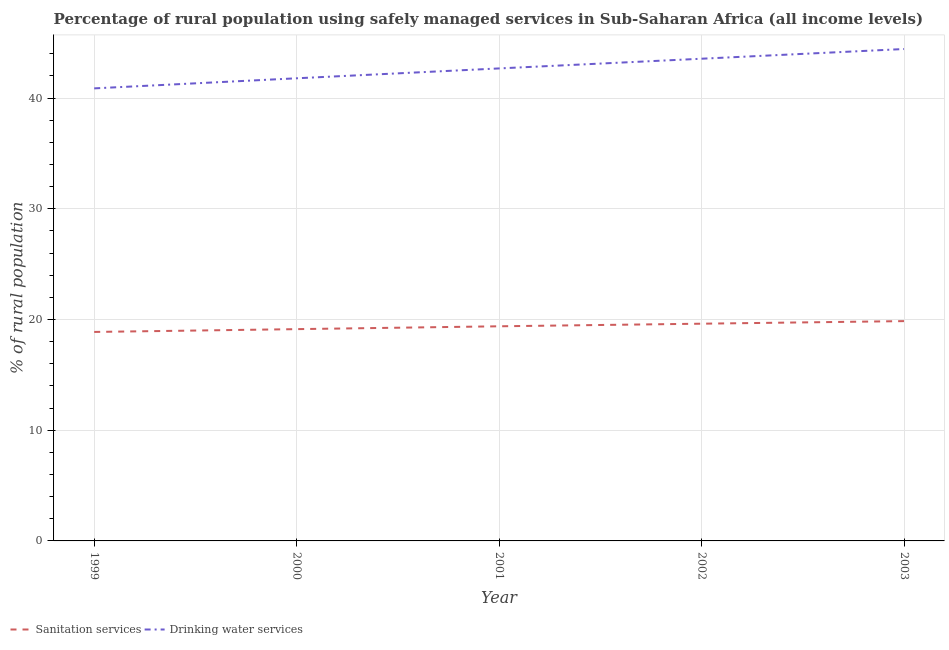Is the number of lines equal to the number of legend labels?
Your response must be concise. Yes. What is the percentage of rural population who used drinking water services in 1999?
Provide a short and direct response. 40.87. Across all years, what is the maximum percentage of rural population who used sanitation services?
Provide a succinct answer. 19.85. Across all years, what is the minimum percentage of rural population who used drinking water services?
Offer a very short reply. 40.87. What is the total percentage of rural population who used sanitation services in the graph?
Your answer should be very brief. 96.85. What is the difference between the percentage of rural population who used drinking water services in 1999 and that in 2002?
Ensure brevity in your answer.  -2.68. What is the difference between the percentage of rural population who used sanitation services in 1999 and the percentage of rural population who used drinking water services in 2001?
Your answer should be compact. -23.8. What is the average percentage of rural population who used drinking water services per year?
Offer a terse response. 42.66. In the year 2000, what is the difference between the percentage of rural population who used drinking water services and percentage of rural population who used sanitation services?
Provide a short and direct response. 22.65. In how many years, is the percentage of rural population who used drinking water services greater than 40 %?
Your response must be concise. 5. What is the ratio of the percentage of rural population who used drinking water services in 1999 to that in 2002?
Offer a very short reply. 0.94. Is the difference between the percentage of rural population who used sanitation services in 2001 and 2002 greater than the difference between the percentage of rural population who used drinking water services in 2001 and 2002?
Offer a terse response. Yes. What is the difference between the highest and the second highest percentage of rural population who used drinking water services?
Provide a short and direct response. 0.88. What is the difference between the highest and the lowest percentage of rural population who used sanitation services?
Offer a terse response. 0.98. In how many years, is the percentage of rural population who used sanitation services greater than the average percentage of rural population who used sanitation services taken over all years?
Offer a very short reply. 3. Is the percentage of rural population who used drinking water services strictly greater than the percentage of rural population who used sanitation services over the years?
Provide a succinct answer. Yes. How many years are there in the graph?
Ensure brevity in your answer.  5. What is the difference between two consecutive major ticks on the Y-axis?
Provide a succinct answer. 10. Are the values on the major ticks of Y-axis written in scientific E-notation?
Keep it short and to the point. No. How are the legend labels stacked?
Provide a short and direct response. Horizontal. What is the title of the graph?
Ensure brevity in your answer.  Percentage of rural population using safely managed services in Sub-Saharan Africa (all income levels). What is the label or title of the Y-axis?
Provide a succinct answer. % of rural population. What is the % of rural population in Sanitation services in 1999?
Make the answer very short. 18.87. What is the % of rural population of Drinking water services in 1999?
Make the answer very short. 40.87. What is the % of rural population in Sanitation services in 2000?
Ensure brevity in your answer.  19.13. What is the % of rural population of Drinking water services in 2000?
Offer a very short reply. 41.78. What is the % of rural population in Sanitation services in 2001?
Your answer should be compact. 19.38. What is the % of rural population in Drinking water services in 2001?
Your response must be concise. 42.67. What is the % of rural population of Sanitation services in 2002?
Provide a short and direct response. 19.62. What is the % of rural population in Drinking water services in 2002?
Your response must be concise. 43.55. What is the % of rural population in Sanitation services in 2003?
Keep it short and to the point. 19.85. What is the % of rural population of Drinking water services in 2003?
Your answer should be very brief. 44.42. Across all years, what is the maximum % of rural population of Sanitation services?
Your response must be concise. 19.85. Across all years, what is the maximum % of rural population of Drinking water services?
Offer a terse response. 44.42. Across all years, what is the minimum % of rural population in Sanitation services?
Your answer should be compact. 18.87. Across all years, what is the minimum % of rural population of Drinking water services?
Offer a terse response. 40.87. What is the total % of rural population of Sanitation services in the graph?
Give a very brief answer. 96.85. What is the total % of rural population of Drinking water services in the graph?
Your response must be concise. 213.3. What is the difference between the % of rural population of Sanitation services in 1999 and that in 2000?
Provide a short and direct response. -0.25. What is the difference between the % of rural population in Drinking water services in 1999 and that in 2000?
Your response must be concise. -0.91. What is the difference between the % of rural population in Sanitation services in 1999 and that in 2001?
Your answer should be very brief. -0.51. What is the difference between the % of rural population in Drinking water services in 1999 and that in 2001?
Keep it short and to the point. -1.8. What is the difference between the % of rural population in Sanitation services in 1999 and that in 2002?
Provide a short and direct response. -0.74. What is the difference between the % of rural population of Drinking water services in 1999 and that in 2002?
Your answer should be very brief. -2.68. What is the difference between the % of rural population of Sanitation services in 1999 and that in 2003?
Your answer should be compact. -0.98. What is the difference between the % of rural population of Drinking water services in 1999 and that in 2003?
Your answer should be very brief. -3.55. What is the difference between the % of rural population in Sanitation services in 2000 and that in 2001?
Make the answer very short. -0.26. What is the difference between the % of rural population in Drinking water services in 2000 and that in 2001?
Ensure brevity in your answer.  -0.89. What is the difference between the % of rural population of Sanitation services in 2000 and that in 2002?
Your answer should be compact. -0.49. What is the difference between the % of rural population in Drinking water services in 2000 and that in 2002?
Ensure brevity in your answer.  -1.77. What is the difference between the % of rural population of Sanitation services in 2000 and that in 2003?
Your answer should be compact. -0.72. What is the difference between the % of rural population in Drinking water services in 2000 and that in 2003?
Ensure brevity in your answer.  -2.64. What is the difference between the % of rural population of Sanitation services in 2001 and that in 2002?
Provide a succinct answer. -0.23. What is the difference between the % of rural population in Drinking water services in 2001 and that in 2002?
Ensure brevity in your answer.  -0.88. What is the difference between the % of rural population of Sanitation services in 2001 and that in 2003?
Offer a very short reply. -0.47. What is the difference between the % of rural population in Drinking water services in 2001 and that in 2003?
Provide a short and direct response. -1.75. What is the difference between the % of rural population of Sanitation services in 2002 and that in 2003?
Provide a short and direct response. -0.23. What is the difference between the % of rural population in Drinking water services in 2002 and that in 2003?
Give a very brief answer. -0.88. What is the difference between the % of rural population of Sanitation services in 1999 and the % of rural population of Drinking water services in 2000?
Keep it short and to the point. -22.91. What is the difference between the % of rural population of Sanitation services in 1999 and the % of rural population of Drinking water services in 2001?
Keep it short and to the point. -23.8. What is the difference between the % of rural population in Sanitation services in 1999 and the % of rural population in Drinking water services in 2002?
Ensure brevity in your answer.  -24.67. What is the difference between the % of rural population in Sanitation services in 1999 and the % of rural population in Drinking water services in 2003?
Provide a short and direct response. -25.55. What is the difference between the % of rural population of Sanitation services in 2000 and the % of rural population of Drinking water services in 2001?
Provide a succinct answer. -23.55. What is the difference between the % of rural population of Sanitation services in 2000 and the % of rural population of Drinking water services in 2002?
Offer a terse response. -24.42. What is the difference between the % of rural population of Sanitation services in 2000 and the % of rural population of Drinking water services in 2003?
Make the answer very short. -25.3. What is the difference between the % of rural population in Sanitation services in 2001 and the % of rural population in Drinking water services in 2002?
Offer a very short reply. -24.16. What is the difference between the % of rural population in Sanitation services in 2001 and the % of rural population in Drinking water services in 2003?
Your answer should be compact. -25.04. What is the difference between the % of rural population of Sanitation services in 2002 and the % of rural population of Drinking water services in 2003?
Give a very brief answer. -24.81. What is the average % of rural population in Sanitation services per year?
Provide a succinct answer. 19.37. What is the average % of rural population of Drinking water services per year?
Provide a succinct answer. 42.66. In the year 1999, what is the difference between the % of rural population in Sanitation services and % of rural population in Drinking water services?
Provide a succinct answer. -22. In the year 2000, what is the difference between the % of rural population in Sanitation services and % of rural population in Drinking water services?
Your answer should be very brief. -22.65. In the year 2001, what is the difference between the % of rural population of Sanitation services and % of rural population of Drinking water services?
Your response must be concise. -23.29. In the year 2002, what is the difference between the % of rural population in Sanitation services and % of rural population in Drinking water services?
Keep it short and to the point. -23.93. In the year 2003, what is the difference between the % of rural population in Sanitation services and % of rural population in Drinking water services?
Your answer should be compact. -24.57. What is the ratio of the % of rural population of Sanitation services in 1999 to that in 2000?
Keep it short and to the point. 0.99. What is the ratio of the % of rural population in Drinking water services in 1999 to that in 2000?
Offer a terse response. 0.98. What is the ratio of the % of rural population in Sanitation services in 1999 to that in 2001?
Keep it short and to the point. 0.97. What is the ratio of the % of rural population in Drinking water services in 1999 to that in 2001?
Your response must be concise. 0.96. What is the ratio of the % of rural population of Sanitation services in 1999 to that in 2002?
Your response must be concise. 0.96. What is the ratio of the % of rural population in Drinking water services in 1999 to that in 2002?
Give a very brief answer. 0.94. What is the ratio of the % of rural population in Sanitation services in 1999 to that in 2003?
Your response must be concise. 0.95. What is the ratio of the % of rural population of Sanitation services in 2000 to that in 2001?
Keep it short and to the point. 0.99. What is the ratio of the % of rural population of Drinking water services in 2000 to that in 2001?
Offer a very short reply. 0.98. What is the ratio of the % of rural population in Sanitation services in 2000 to that in 2002?
Offer a very short reply. 0.97. What is the ratio of the % of rural population of Drinking water services in 2000 to that in 2002?
Keep it short and to the point. 0.96. What is the ratio of the % of rural population in Sanitation services in 2000 to that in 2003?
Provide a succinct answer. 0.96. What is the ratio of the % of rural population of Drinking water services in 2000 to that in 2003?
Make the answer very short. 0.94. What is the ratio of the % of rural population of Drinking water services in 2001 to that in 2002?
Provide a short and direct response. 0.98. What is the ratio of the % of rural population in Sanitation services in 2001 to that in 2003?
Your response must be concise. 0.98. What is the ratio of the % of rural population in Drinking water services in 2001 to that in 2003?
Offer a terse response. 0.96. What is the ratio of the % of rural population of Sanitation services in 2002 to that in 2003?
Make the answer very short. 0.99. What is the ratio of the % of rural population of Drinking water services in 2002 to that in 2003?
Provide a succinct answer. 0.98. What is the difference between the highest and the second highest % of rural population of Sanitation services?
Provide a short and direct response. 0.23. What is the difference between the highest and the second highest % of rural population of Drinking water services?
Offer a very short reply. 0.88. What is the difference between the highest and the lowest % of rural population of Sanitation services?
Offer a very short reply. 0.98. What is the difference between the highest and the lowest % of rural population of Drinking water services?
Your response must be concise. 3.55. 